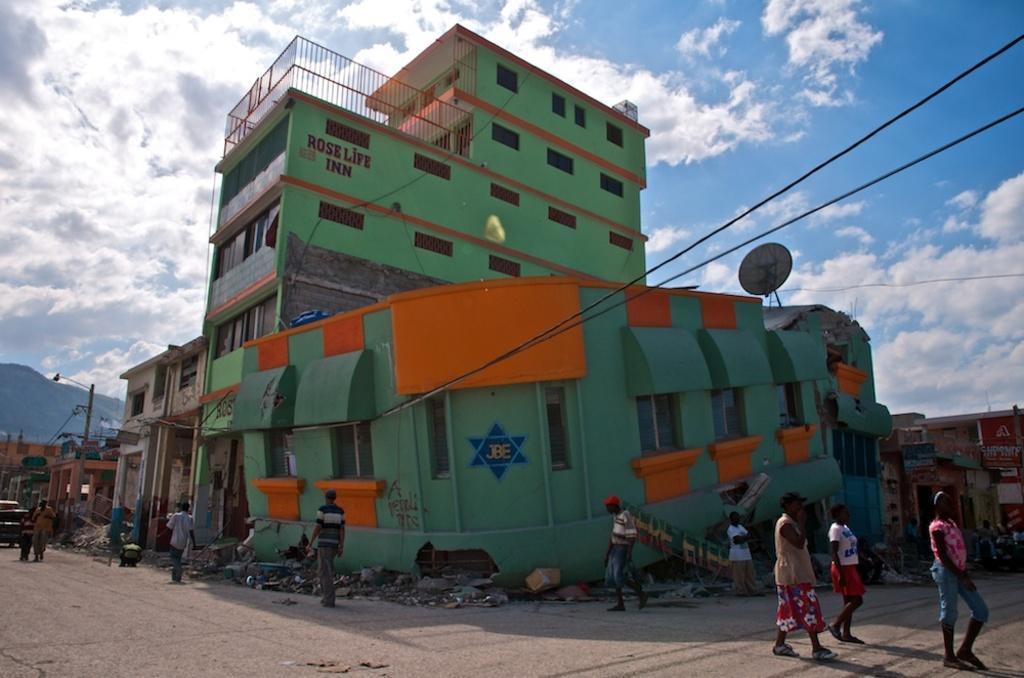How would you summarize this image in a sentence or two? In this picture we can see a group of people are walking on the path and behind the people there are buildings, electric poles with cables. Behind the buildings there is a hill and a sky. 